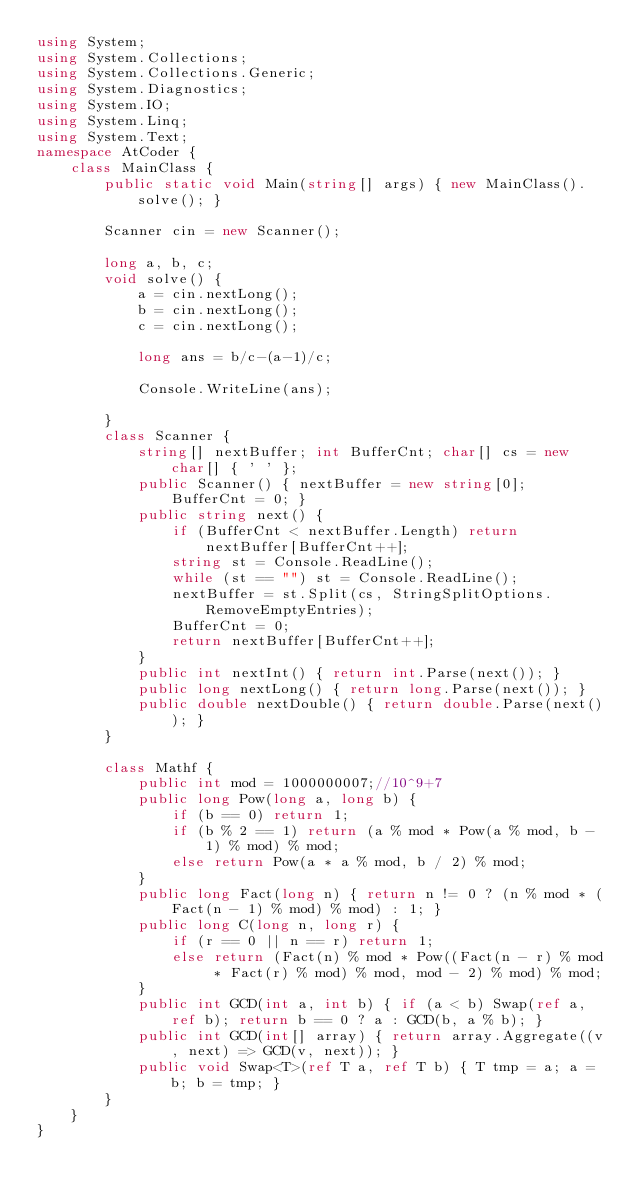Convert code to text. <code><loc_0><loc_0><loc_500><loc_500><_C#_>using System;
using System.Collections;
using System.Collections.Generic;
using System.Diagnostics;
using System.IO;
using System.Linq;
using System.Text;
namespace AtCoder {
    class MainClass {
        public static void Main(string[] args) { new MainClass().solve(); }

        Scanner cin = new Scanner();

        long a, b, c;
        void solve() {
            a = cin.nextLong();
            b = cin.nextLong();
            c = cin.nextLong();

            long ans = b/c-(a-1)/c;

            Console.WriteLine(ans);

        }
        class Scanner {
            string[] nextBuffer; int BufferCnt; char[] cs = new char[] { ' ' };
            public Scanner() { nextBuffer = new string[0]; BufferCnt = 0; }
            public string next() {
                if (BufferCnt < nextBuffer.Length) return nextBuffer[BufferCnt++];
                string st = Console.ReadLine();
                while (st == "") st = Console.ReadLine();
                nextBuffer = st.Split(cs, StringSplitOptions.RemoveEmptyEntries);
                BufferCnt = 0;
                return nextBuffer[BufferCnt++];
            }
            public int nextInt() { return int.Parse(next()); }
            public long nextLong() { return long.Parse(next()); }
            public double nextDouble() { return double.Parse(next()); }
        }

        class Mathf {
            public int mod = 1000000007;//10^9+7
            public long Pow(long a, long b) {
                if (b == 0) return 1;
                if (b % 2 == 1) return (a % mod * Pow(a % mod, b - 1) % mod) % mod;
                else return Pow(a * a % mod, b / 2) % mod;
            }
            public long Fact(long n) { return n != 0 ? (n % mod * (Fact(n - 1) % mod) % mod) : 1; }
            public long C(long n, long r) {
                if (r == 0 || n == r) return 1;
                else return (Fact(n) % mod * Pow((Fact(n - r) % mod * Fact(r) % mod) % mod, mod - 2) % mod) % mod;
            }
            public int GCD(int a, int b) { if (a < b) Swap(ref a, ref b); return b == 0 ? a : GCD(b, a % b); }
            public int GCD(int[] array) { return array.Aggregate((v, next) => GCD(v, next)); }
            public void Swap<T>(ref T a, ref T b) { T tmp = a; a = b; b = tmp; }
        }
    }
}</code> 